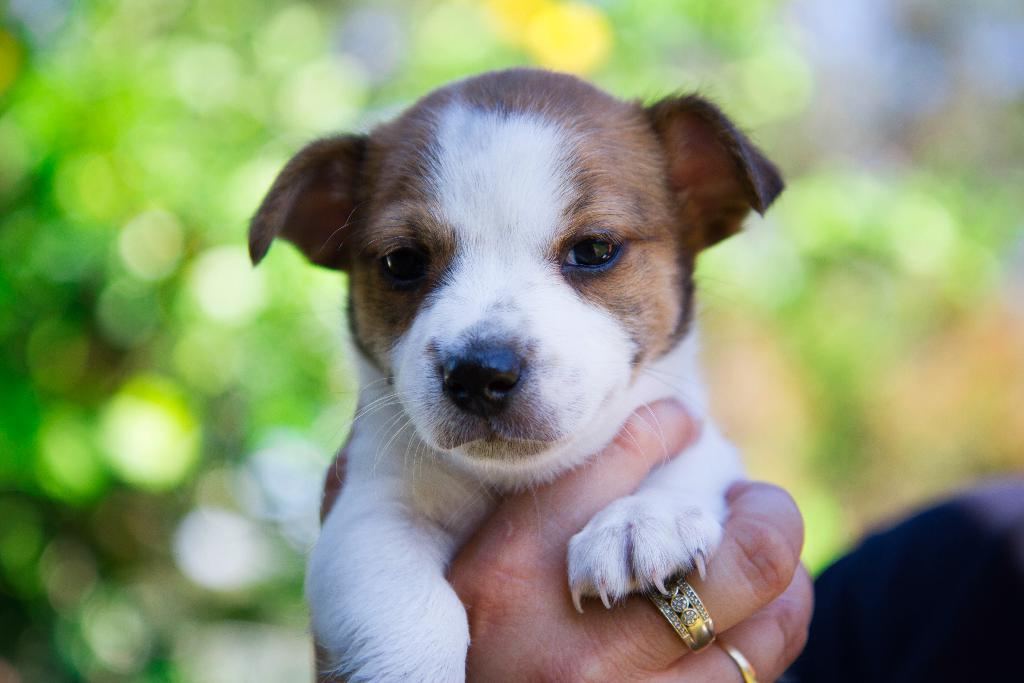What can be seen in the person's hand in the image? The hand is holding a dog in the image. Are there any accessories on the hand? Yes, there are rings on the fingers of the hand. Can you describe the background of the image? The background of the image is blurred. What type of silk is being used to make the potato in the image? There is no silk or potato present in the image. What is the governor's stance on the issue depicted in the image? There is no reference to a governor or any issue in the image. 